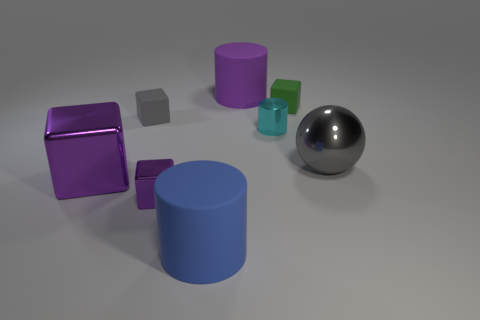Subtract all small shiny cylinders. How many cylinders are left? 2 How many purple blocks must be subtracted to get 1 purple blocks? 1 Subtract 2 cubes. How many cubes are left? 2 Subtract all blue cubes. Subtract all cyan spheres. How many cubes are left? 4 Subtract all blue cylinders. How many gray blocks are left? 1 Subtract all green matte blocks. Subtract all cyan cylinders. How many objects are left? 6 Add 5 purple cylinders. How many purple cylinders are left? 6 Add 6 tiny cyan metallic objects. How many tiny cyan metallic objects exist? 7 Add 1 blue objects. How many objects exist? 9 Subtract all green blocks. How many blocks are left? 3 